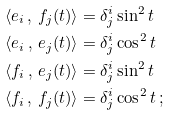<formula> <loc_0><loc_0><loc_500><loc_500>\langle e _ { i } \, , \, f _ { j } ( t ) \rangle & = \delta ^ { i } _ { j } \sin ^ { 2 } { t } \\ \langle e _ { i } \, , \, e _ { j } ( t ) \rangle & = \delta ^ { i } _ { j } \cos ^ { 2 } { t } \\ \langle f _ { i } \, , \, e _ { j } ( t ) \rangle & = \delta ^ { i } _ { j } \sin ^ { 2 } { t } \\ \langle f _ { i } \, , \, f _ { j } ( t ) \rangle & = \delta ^ { i } _ { j } \cos ^ { 2 } { t } \, ;</formula> 